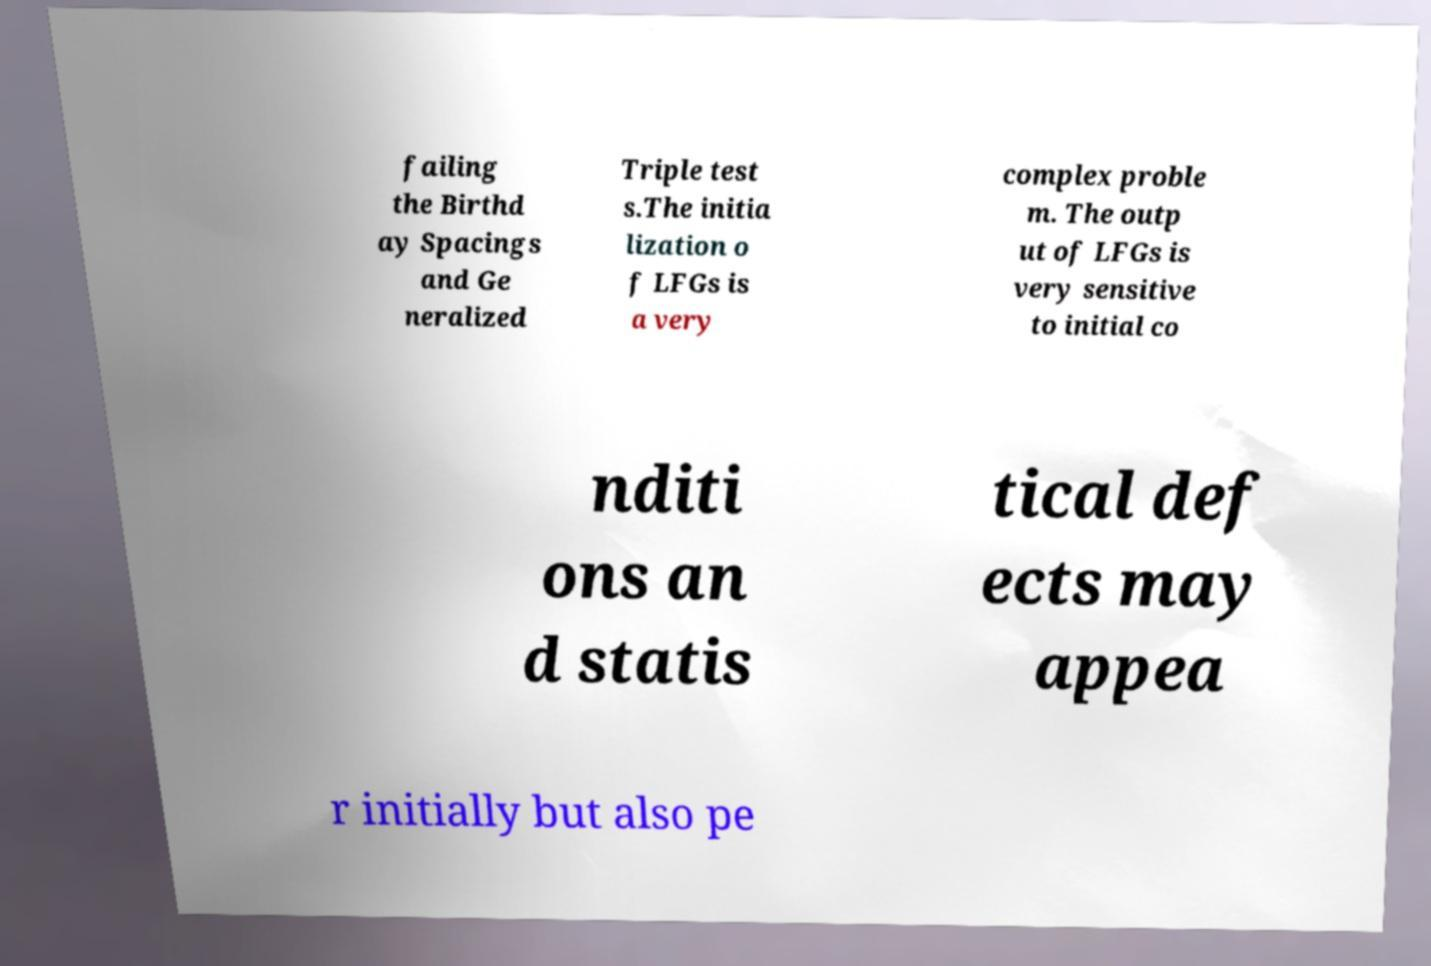Can you read and provide the text displayed in the image?This photo seems to have some interesting text. Can you extract and type it out for me? failing the Birthd ay Spacings and Ge neralized Triple test s.The initia lization o f LFGs is a very complex proble m. The outp ut of LFGs is very sensitive to initial co nditi ons an d statis tical def ects may appea r initially but also pe 